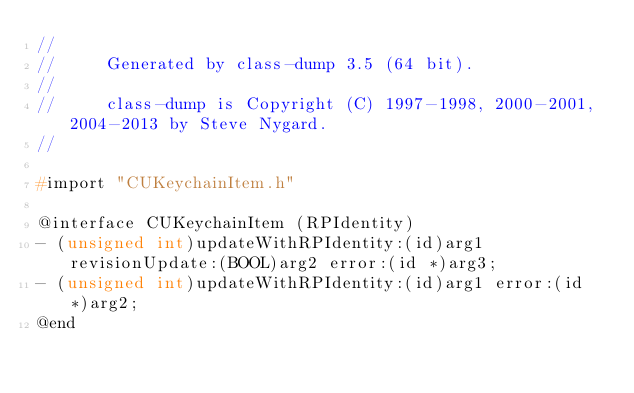Convert code to text. <code><loc_0><loc_0><loc_500><loc_500><_C_>//
//     Generated by class-dump 3.5 (64 bit).
//
//     class-dump is Copyright (C) 1997-1998, 2000-2001, 2004-2013 by Steve Nygard.
//

#import "CUKeychainItem.h"

@interface CUKeychainItem (RPIdentity)
- (unsigned int)updateWithRPIdentity:(id)arg1 revisionUpdate:(BOOL)arg2 error:(id *)arg3;
- (unsigned int)updateWithRPIdentity:(id)arg1 error:(id *)arg2;
@end

</code> 